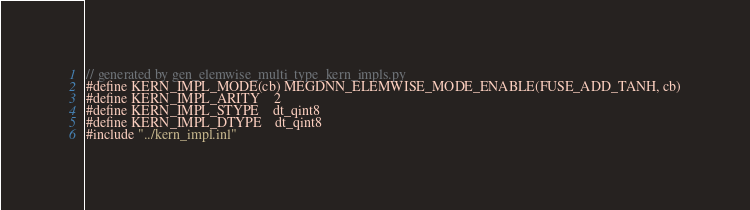<code> <loc_0><loc_0><loc_500><loc_500><_Cuda_>// generated by gen_elemwise_multi_type_kern_impls.py
#define KERN_IMPL_MODE(cb) MEGDNN_ELEMWISE_MODE_ENABLE(FUSE_ADD_TANH, cb)
#define KERN_IMPL_ARITY    2
#define KERN_IMPL_STYPE    dt_qint8
#define KERN_IMPL_DTYPE    dt_qint8
#include "../kern_impl.inl"
</code> 